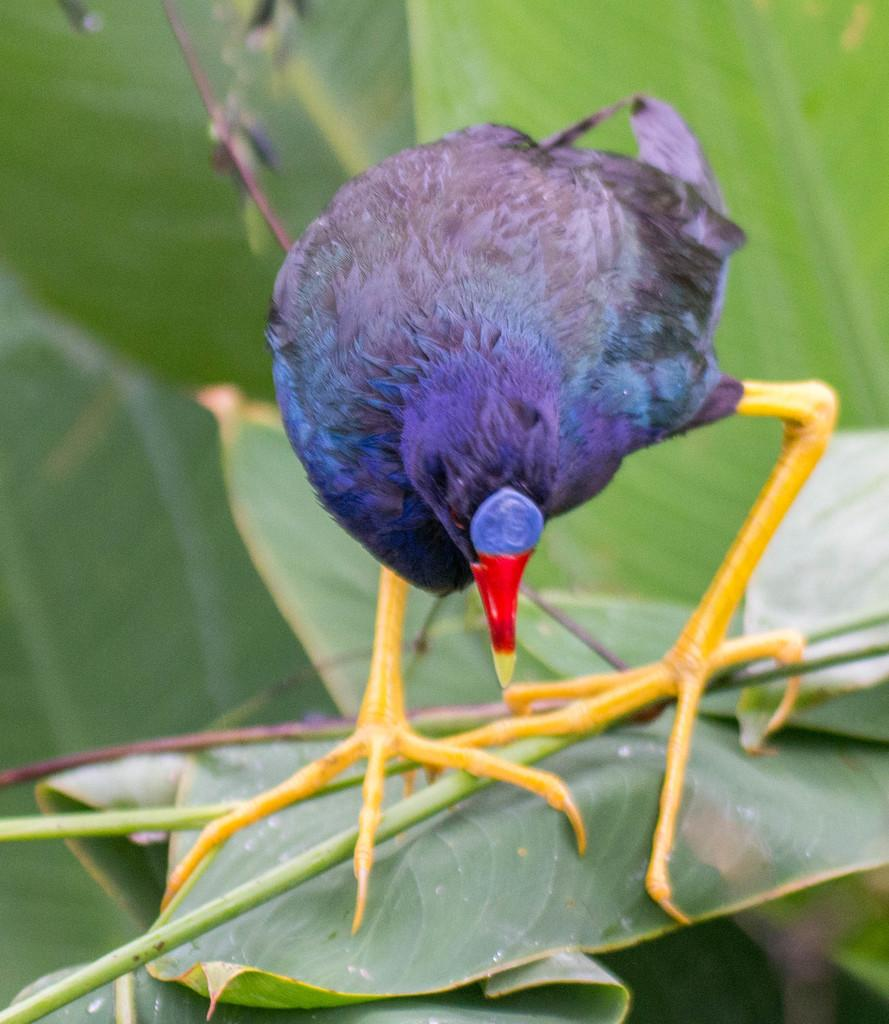What color is the bird in the image? The bird in the image is purple. What is the color of the bird's beak? The bird has a red beak. What is the bird standing on in the image? The bird is standing on green leaves. What type of music can be heard playing in the background of the image? There is no music present in the image, as it is a still photograph of a bird standing on green leaves. 